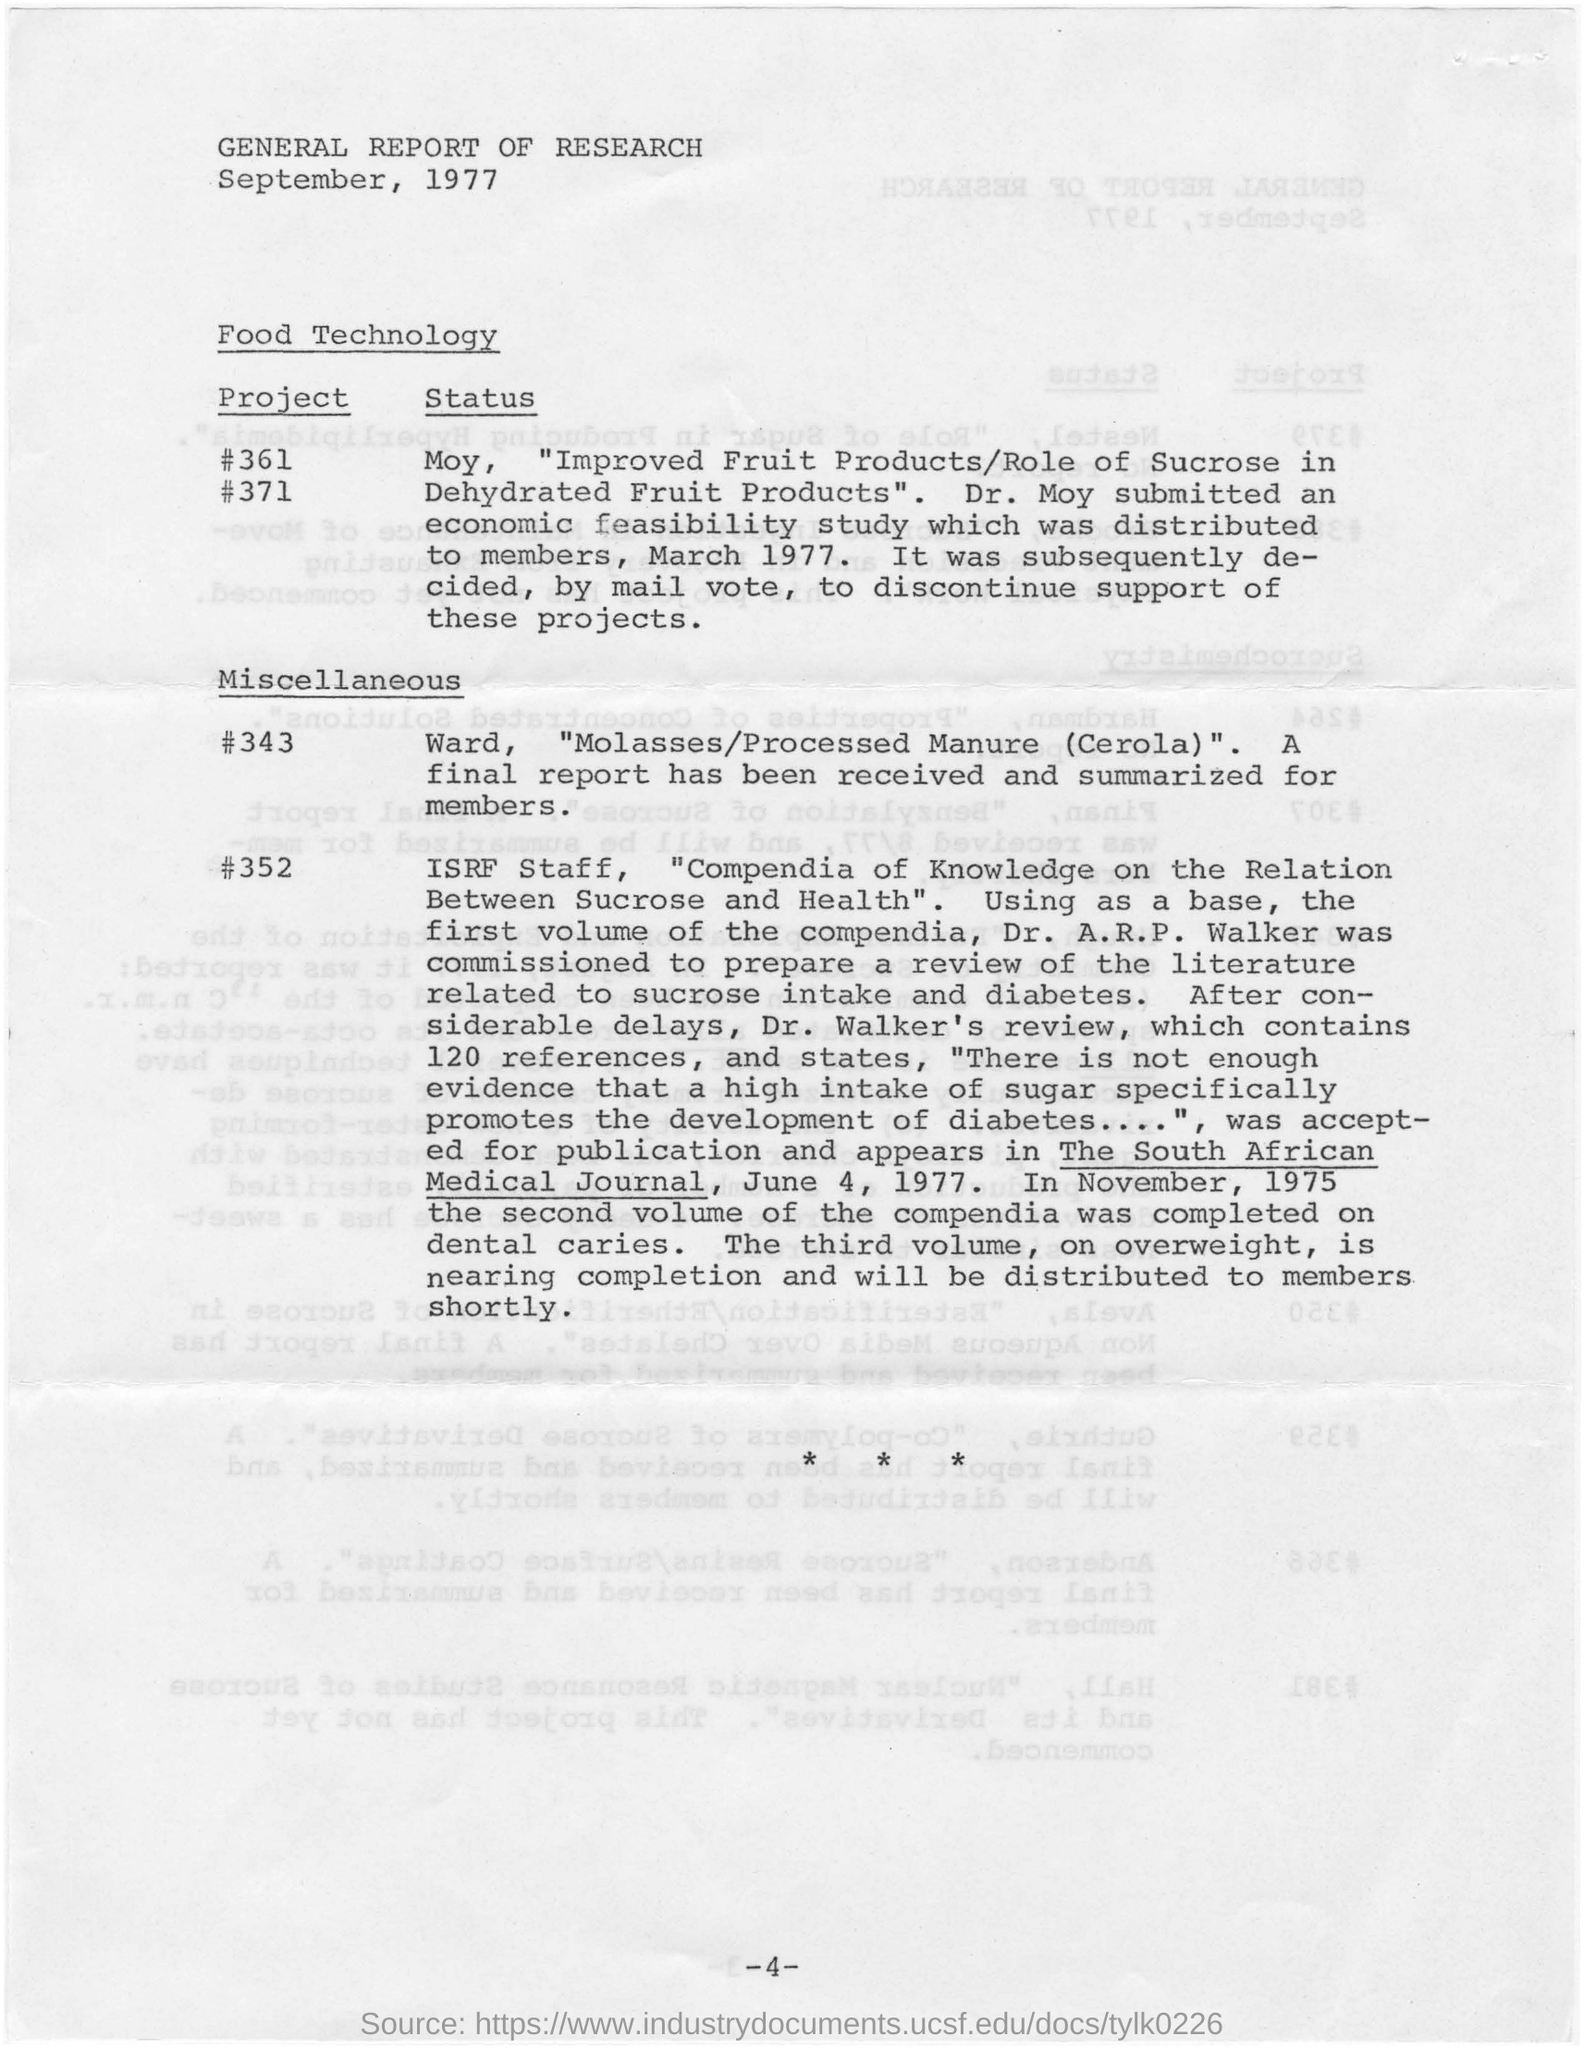Give some essential details in this illustration. The document is about a general report of research. The report is dated in September, 1977. 